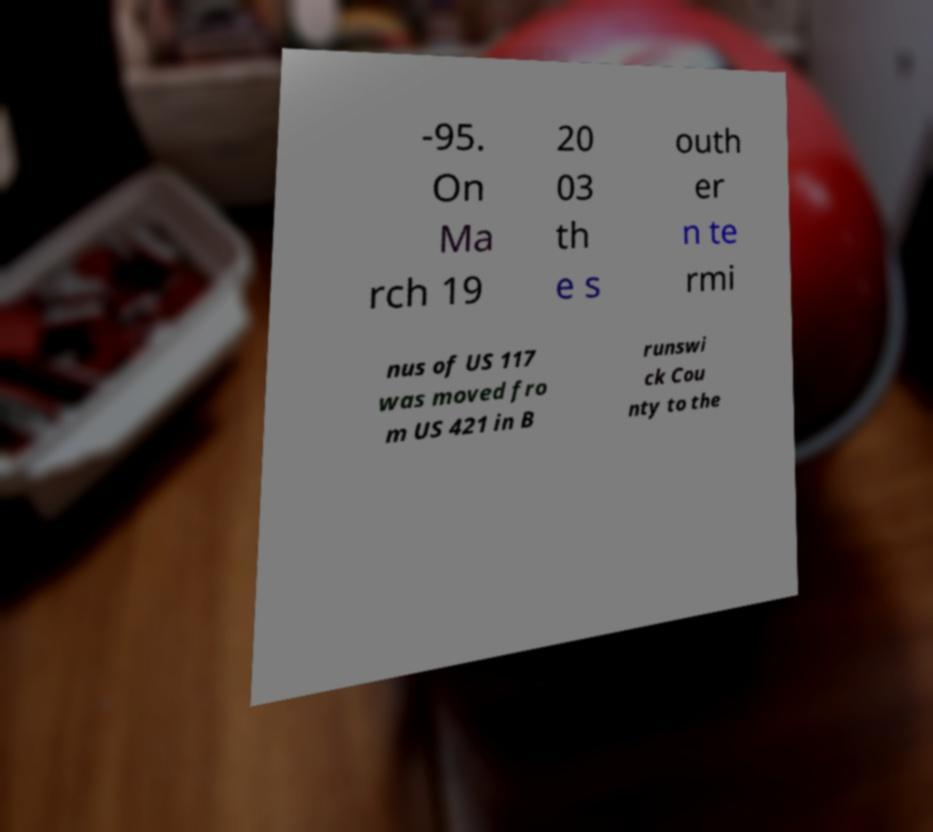What messages or text are displayed in this image? I need them in a readable, typed format. -95. On Ma rch 19 20 03 th e s outh er n te rmi nus of US 117 was moved fro m US 421 in B runswi ck Cou nty to the 